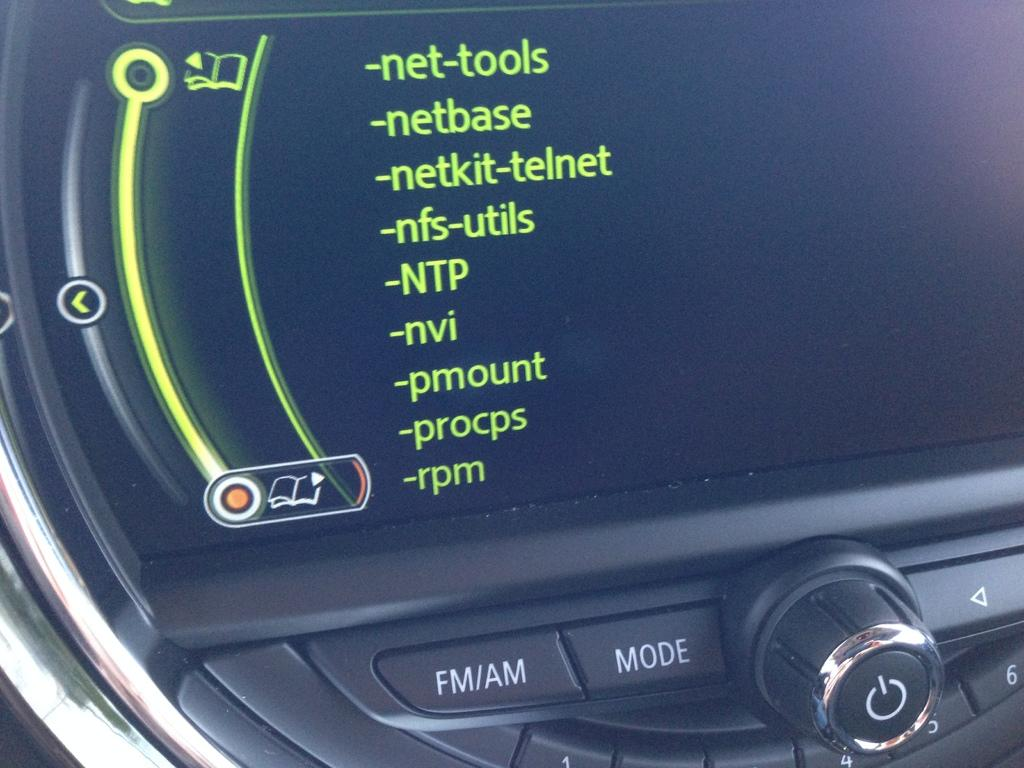What is the main object in the image? There is a screen in the image. What can be seen on the screen? The screen displays some text. Are there any interactive elements on the screen? Yes, there are buttons visible in the image. What type of animal can be seen sleeping on the bed in the image? There is no bed or animal present in the image; it only features a screen with text and buttons. 